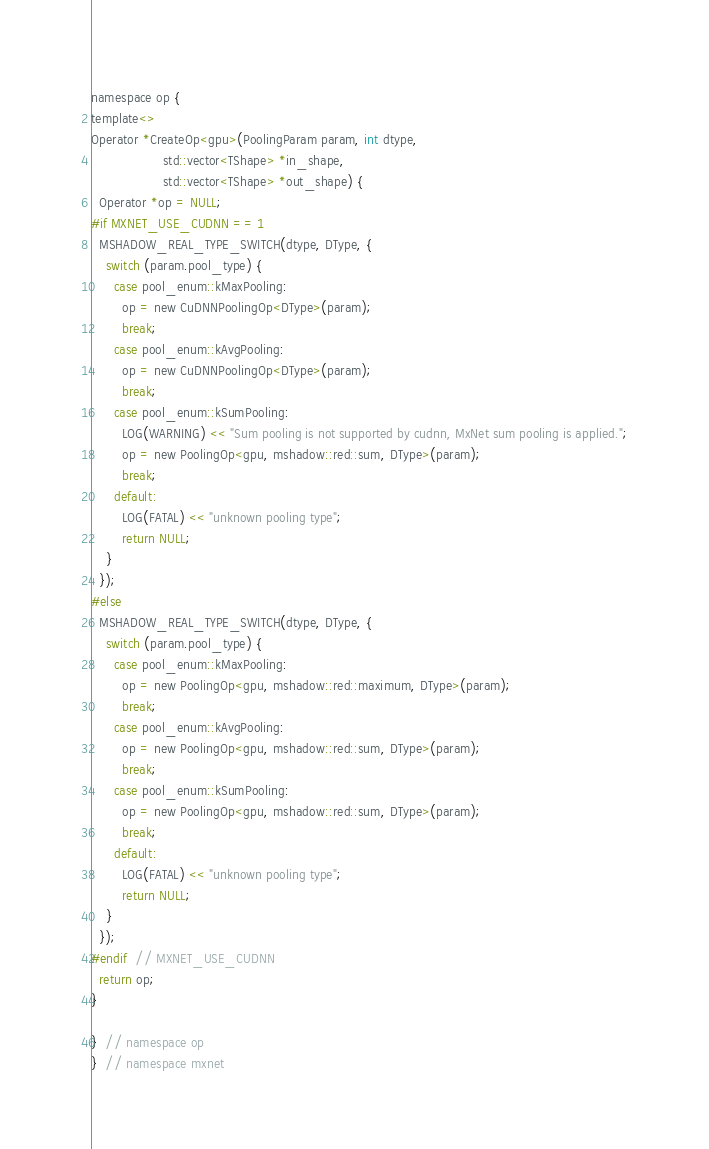<code> <loc_0><loc_0><loc_500><loc_500><_Cuda_>namespace op {
template<>
Operator *CreateOp<gpu>(PoolingParam param, int dtype,
                   std::vector<TShape> *in_shape,
                   std::vector<TShape> *out_shape) {
  Operator *op = NULL;
#if MXNET_USE_CUDNN == 1
  MSHADOW_REAL_TYPE_SWITCH(dtype, DType, {
    switch (param.pool_type) {
      case pool_enum::kMaxPooling:
        op = new CuDNNPoolingOp<DType>(param);
        break;
      case pool_enum::kAvgPooling:
        op = new CuDNNPoolingOp<DType>(param);
        break;
      case pool_enum::kSumPooling:
        LOG(WARNING) << "Sum pooling is not supported by cudnn, MxNet sum pooling is applied.";
        op = new PoolingOp<gpu, mshadow::red::sum, DType>(param);
        break;
      default:
        LOG(FATAL) << "unknown pooling type";
        return NULL;
    }
  });
#else
  MSHADOW_REAL_TYPE_SWITCH(dtype, DType, {
    switch (param.pool_type) {
      case pool_enum::kMaxPooling:
        op = new PoolingOp<gpu, mshadow::red::maximum, DType>(param);
        break;
      case pool_enum::kAvgPooling:
        op = new PoolingOp<gpu, mshadow::red::sum, DType>(param);
        break;
      case pool_enum::kSumPooling:
        op = new PoolingOp<gpu, mshadow::red::sum, DType>(param);
        break;
      default:
        LOG(FATAL) << "unknown pooling type";
        return NULL;
    }
  });
#endif  // MXNET_USE_CUDNN
  return op;
}

}  // namespace op
}  // namespace mxnet

</code> 